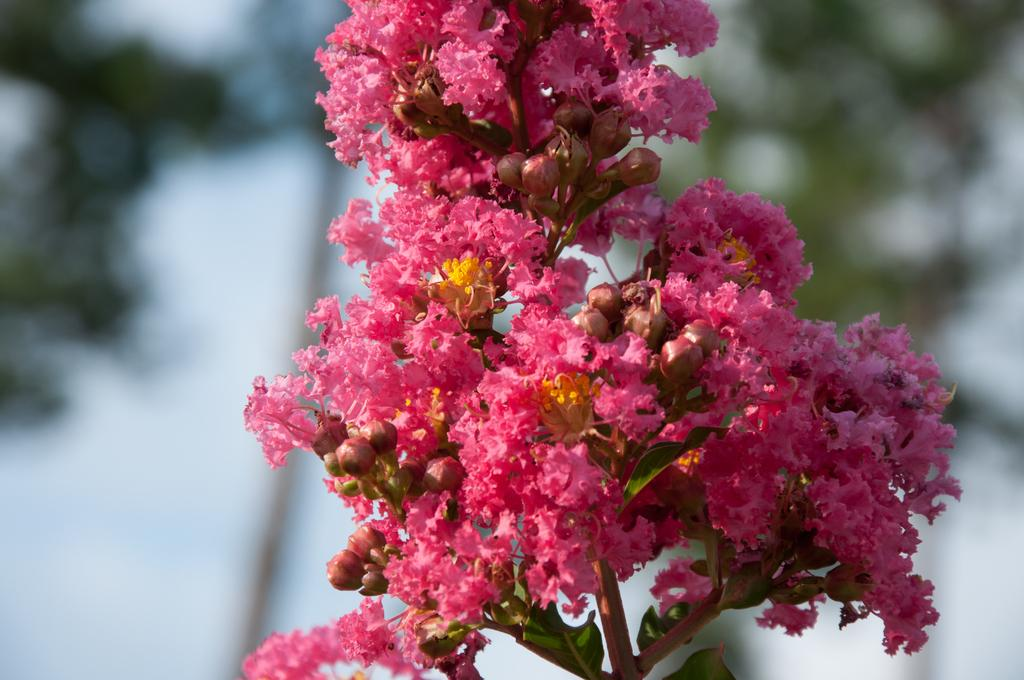What is the main subject of the image? There is a flower in the image. What color is the flower? The flower is pink in color. Can you describe the background of the image? The background of the image is blurry. What type of appliance is causing the disease in the image? There is no appliance or disease present in the image; it features a pink flower with a blurry background. 